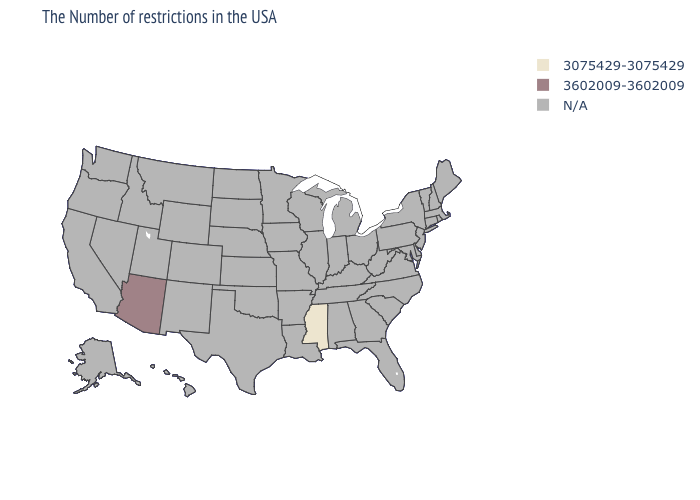What is the value of Kansas?
Answer briefly. N/A. What is the value of Wisconsin?
Quick response, please. N/A. Name the states that have a value in the range N/A?
Short answer required. Maine, Massachusetts, Rhode Island, New Hampshire, Vermont, Connecticut, New York, New Jersey, Delaware, Maryland, Pennsylvania, Virginia, North Carolina, South Carolina, West Virginia, Ohio, Florida, Georgia, Michigan, Kentucky, Indiana, Alabama, Tennessee, Wisconsin, Illinois, Louisiana, Missouri, Arkansas, Minnesota, Iowa, Kansas, Nebraska, Oklahoma, Texas, South Dakota, North Dakota, Wyoming, Colorado, New Mexico, Utah, Montana, Idaho, Nevada, California, Washington, Oregon, Alaska, Hawaii. Name the states that have a value in the range 3075429-3075429?
Answer briefly. Mississippi. What is the value of Louisiana?
Short answer required. N/A. Among the states that border Colorado , which have the highest value?
Give a very brief answer. Arizona. Which states have the lowest value in the USA?
Short answer required. Mississippi. Does the map have missing data?
Keep it brief. Yes. Does Arizona have the highest value in the USA?
Be succinct. Yes. What is the value of Illinois?
Short answer required. N/A. Does the first symbol in the legend represent the smallest category?
Keep it brief. Yes. Does the first symbol in the legend represent the smallest category?
Keep it brief. Yes. 